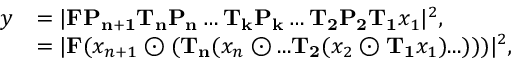Convert formula to latex. <formula><loc_0><loc_0><loc_500><loc_500>\begin{array} { r l } { y } & { = | F P _ { n + 1 } T _ { n } P _ { n } \dots T _ { k } P _ { k } \dots T _ { 2 } P _ { 2 } T _ { 1 } x _ { 1 } | ^ { 2 } , } \\ & { = | F ( x _ { n + 1 } \odot ( T _ { n } ( x _ { n } \odot \dots T _ { 2 } ( x _ { 2 } \odot T _ { 1 } x _ { 1 } ) \dots ) ) ) | ^ { 2 } , } \end{array}</formula> 